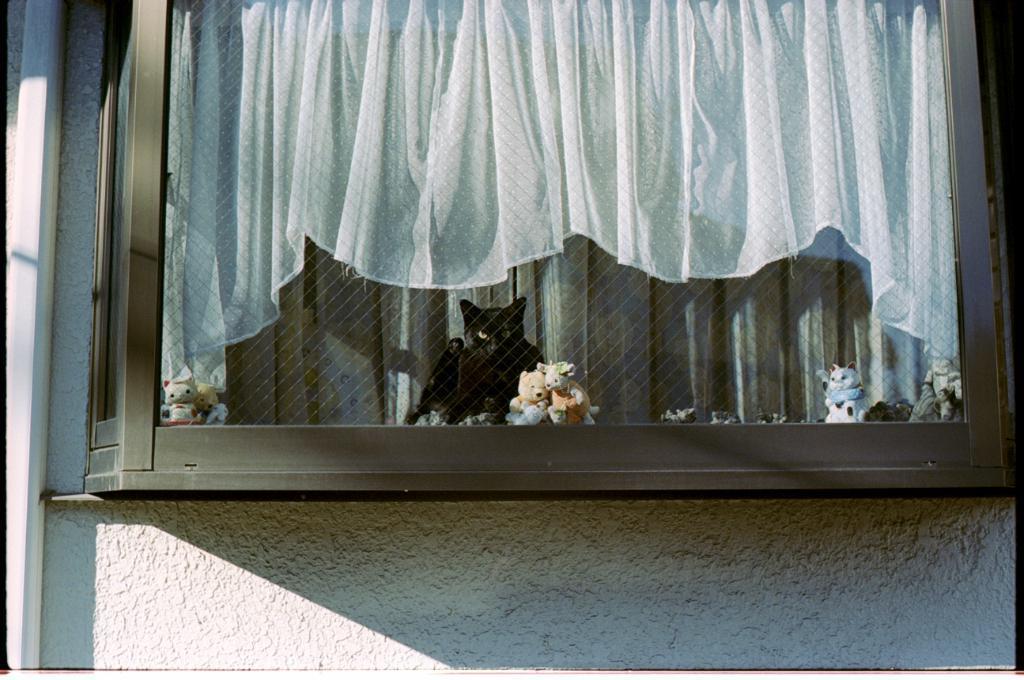Can you describe this image briefly? In this image I can see few toys in multi color and I can also see the cat in black color. In the background I can see the curtain in white color and the wall is in white color. 